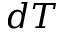<formula> <loc_0><loc_0><loc_500><loc_500>d T</formula> 